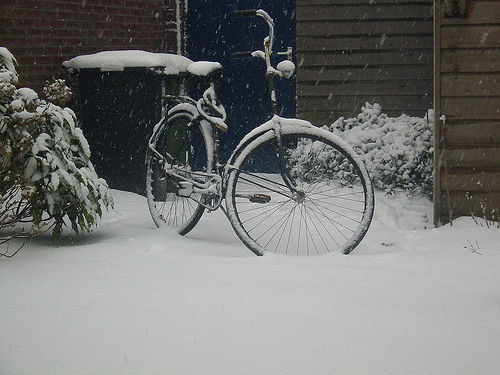How is the composition of the image?
A. excellent with perfect balance
B. well-balanced and aligned
C. not good with a slight tilt The composition of the image has a certain charm with the solitary bicycle covered in snow suggesting a serene and still atmosphere, although there is a slight tilt to the left that disrupts the balance, making the answer 'C' appropriate but not completely encompassing the scene's tranquil beauty. 